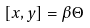<formula> <loc_0><loc_0><loc_500><loc_500>[ x , y ] = \beta \Theta</formula> 